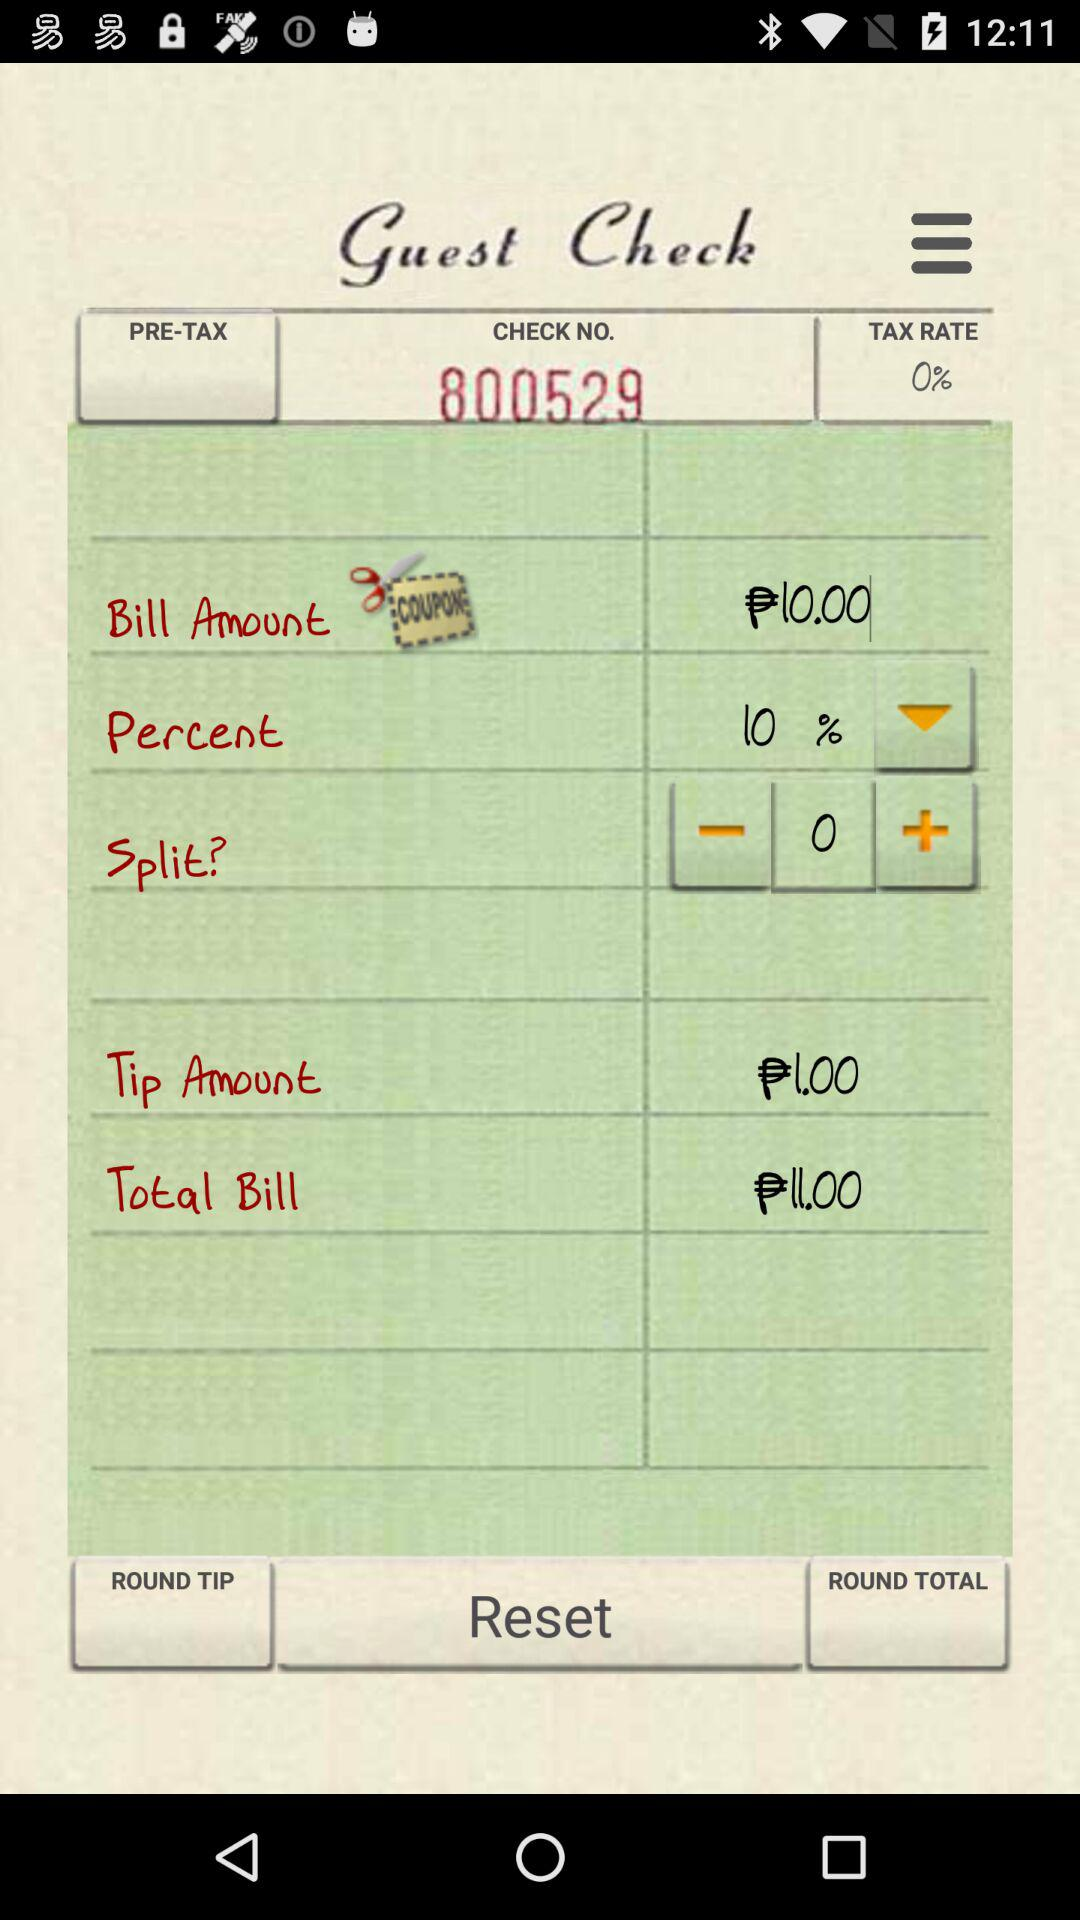What is the tax rate? The tax rate is 0%. 